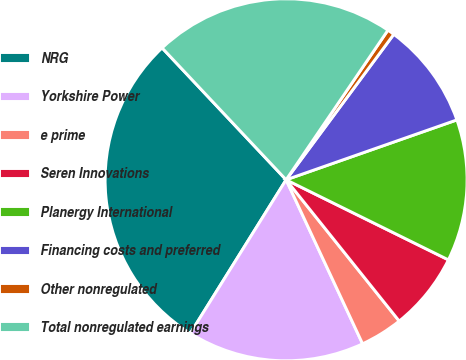Convert chart to OTSL. <chart><loc_0><loc_0><loc_500><loc_500><pie_chart><fcel>NRG<fcel>Yorkshire Power<fcel>e prime<fcel>Seren Innovations<fcel>Planergy International<fcel>Financing costs and preferred<fcel>Other nonregulated<fcel>Total nonregulated earnings<nl><fcel>29.11%<fcel>15.82%<fcel>3.8%<fcel>6.96%<fcel>12.66%<fcel>9.49%<fcel>0.63%<fcel>21.52%<nl></chart> 